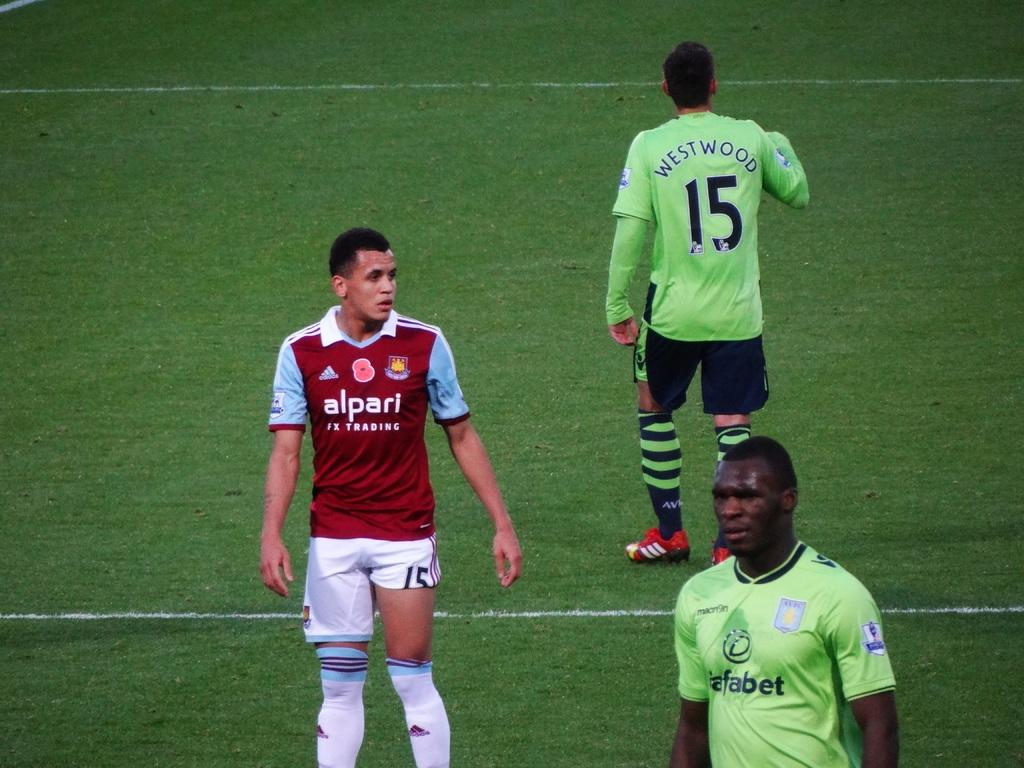<image>
Give a short and clear explanation of the subsequent image. Player number 15 is named Westwood and is wearing striped socks. 